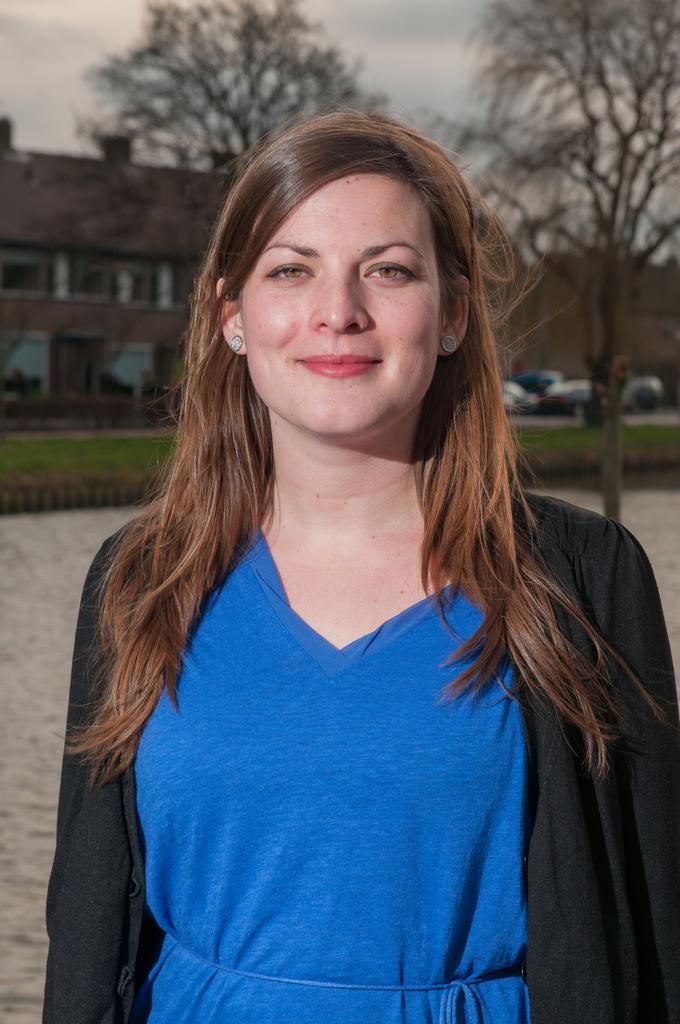Please provide a concise description of this image. In front of the picture, we see the woman in the blue and black dress is stunning. She is smiling and she might be posing for the photo. Behind her, we see a tree and grass. We see the vehicles are moving on the road. In the background, we see the buildings and trees. At the top, we see the sky. At the bottom, we see the pavement or it might be the water. 